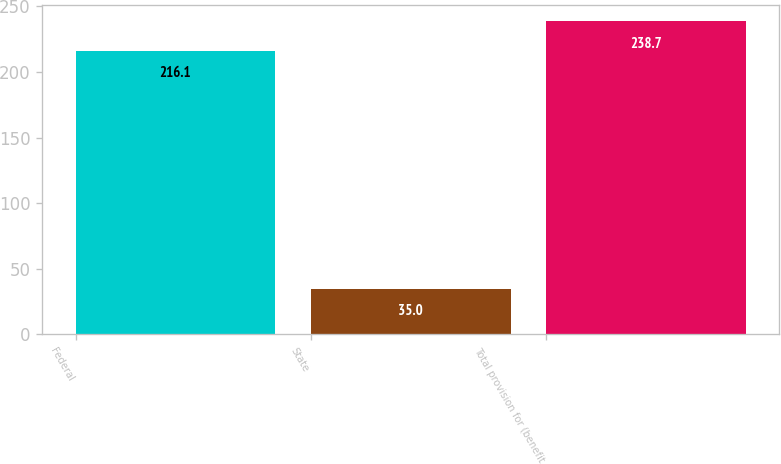Convert chart. <chart><loc_0><loc_0><loc_500><loc_500><bar_chart><fcel>Federal<fcel>State<fcel>Total provision for (benefit<nl><fcel>216.1<fcel>35<fcel>238.7<nl></chart> 